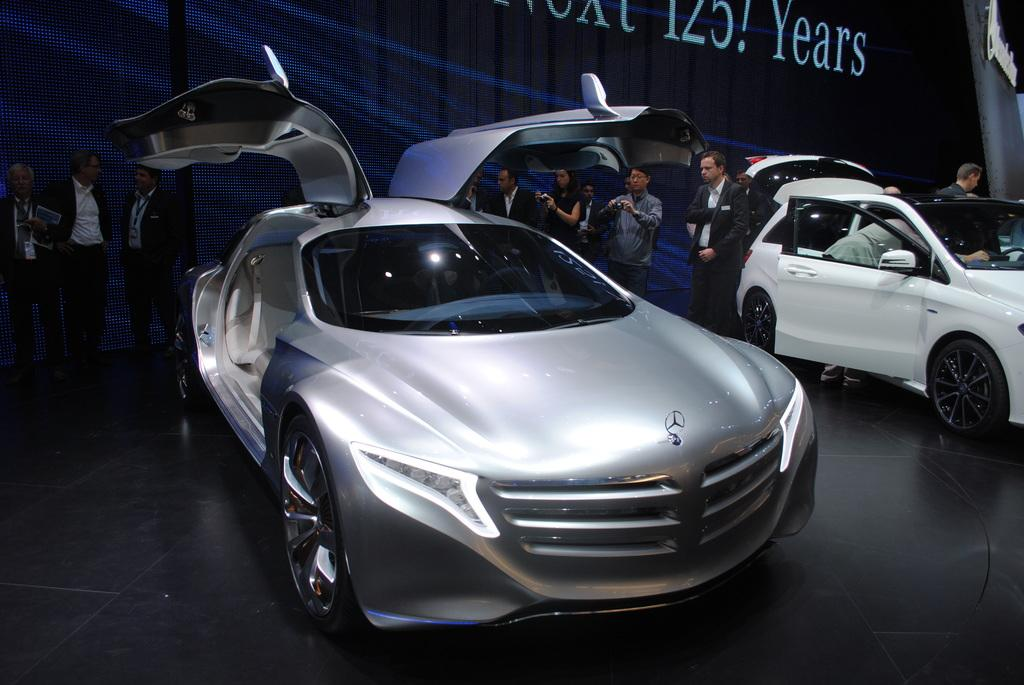What is happening in the background of the image? There are people standing in the background of the image. What are some of the people doing? Some people are holding gadgets, and some are taking snapshots. What can be seen on the floor in the image? There are cars visible on the floor of the image. What is written at the top of the image? There is something written at the top of the image. Can you see any chains hanging from the cars in the image? There are no chains visible in the image; only cars are present on the floor. What type of birds can be seen flying in the image? There are no birds present in the image. 